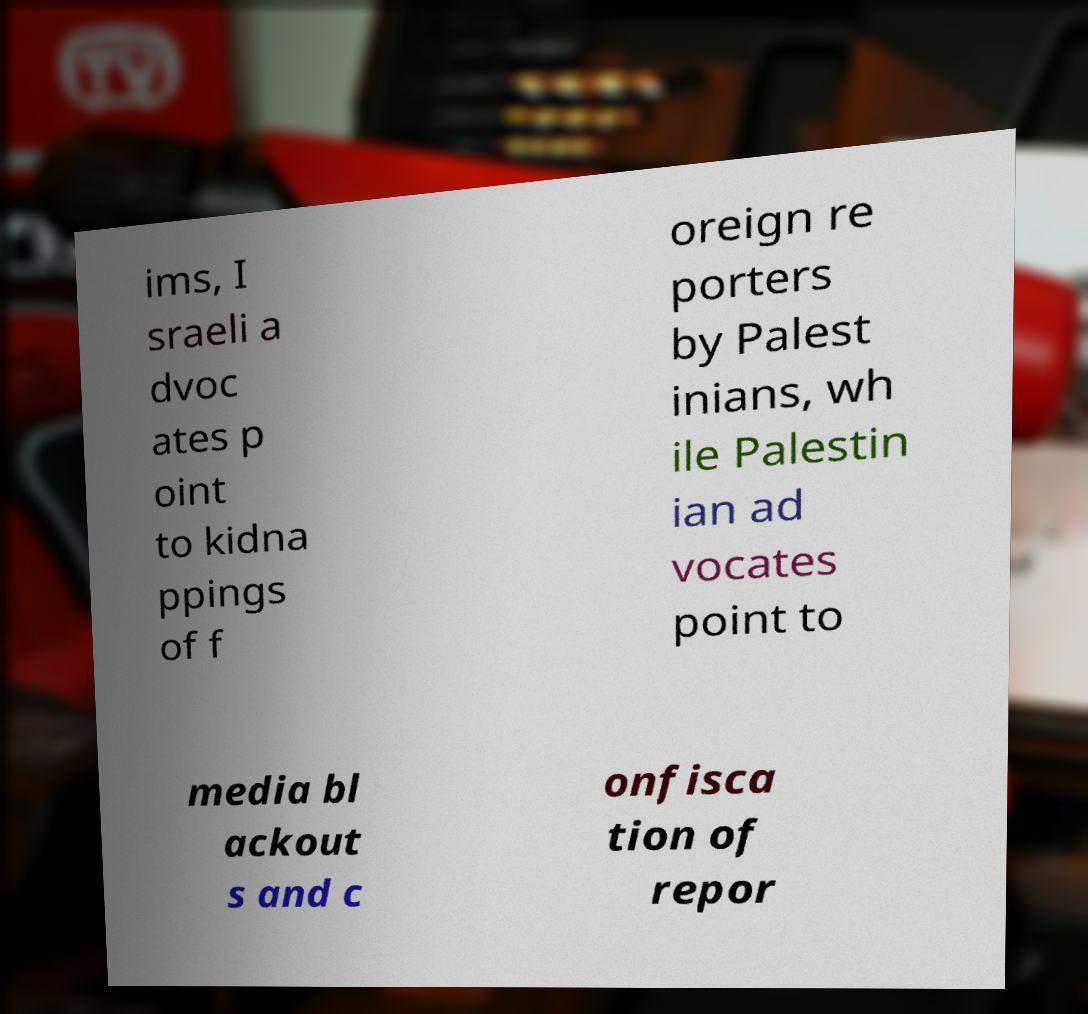Could you extract and type out the text from this image? ims, I sraeli a dvoc ates p oint to kidna ppings of f oreign re porters by Palest inians, wh ile Palestin ian ad vocates point to media bl ackout s and c onfisca tion of repor 